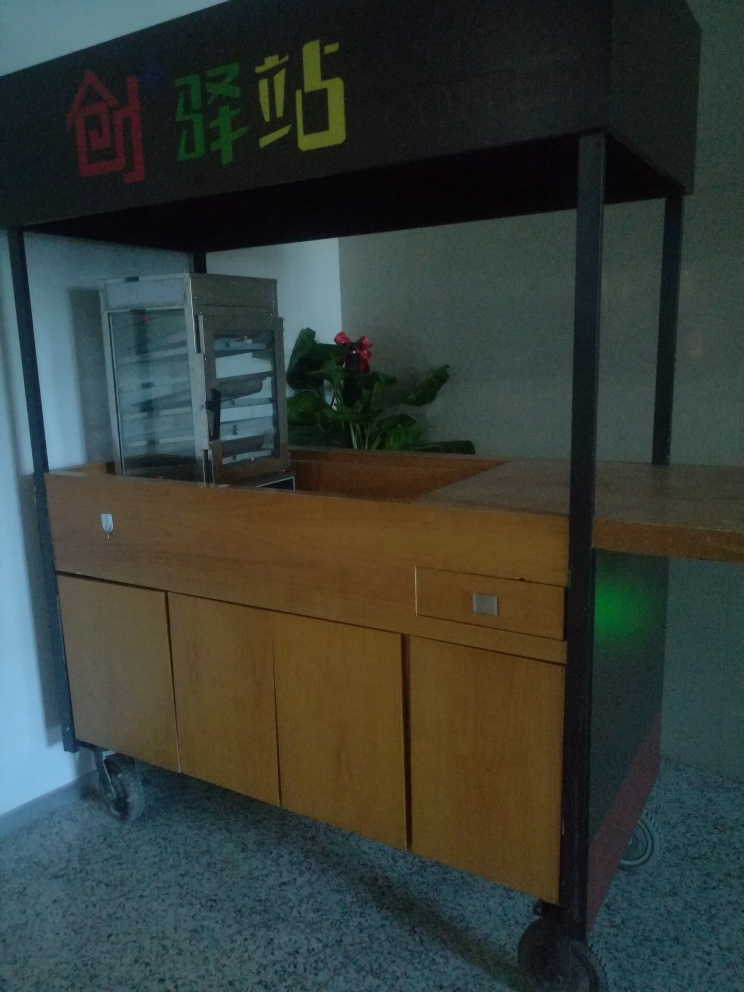What could be the purpose of this location? The area looks like an information or reception desk inside a building. It could serve as a point where visitors or clients are greeted, provided with information, or directed to different areas. The overhead signage suggests this could be a specialized counter, perhaps for real estate or housing services, as indicated by the house symbol and text. 